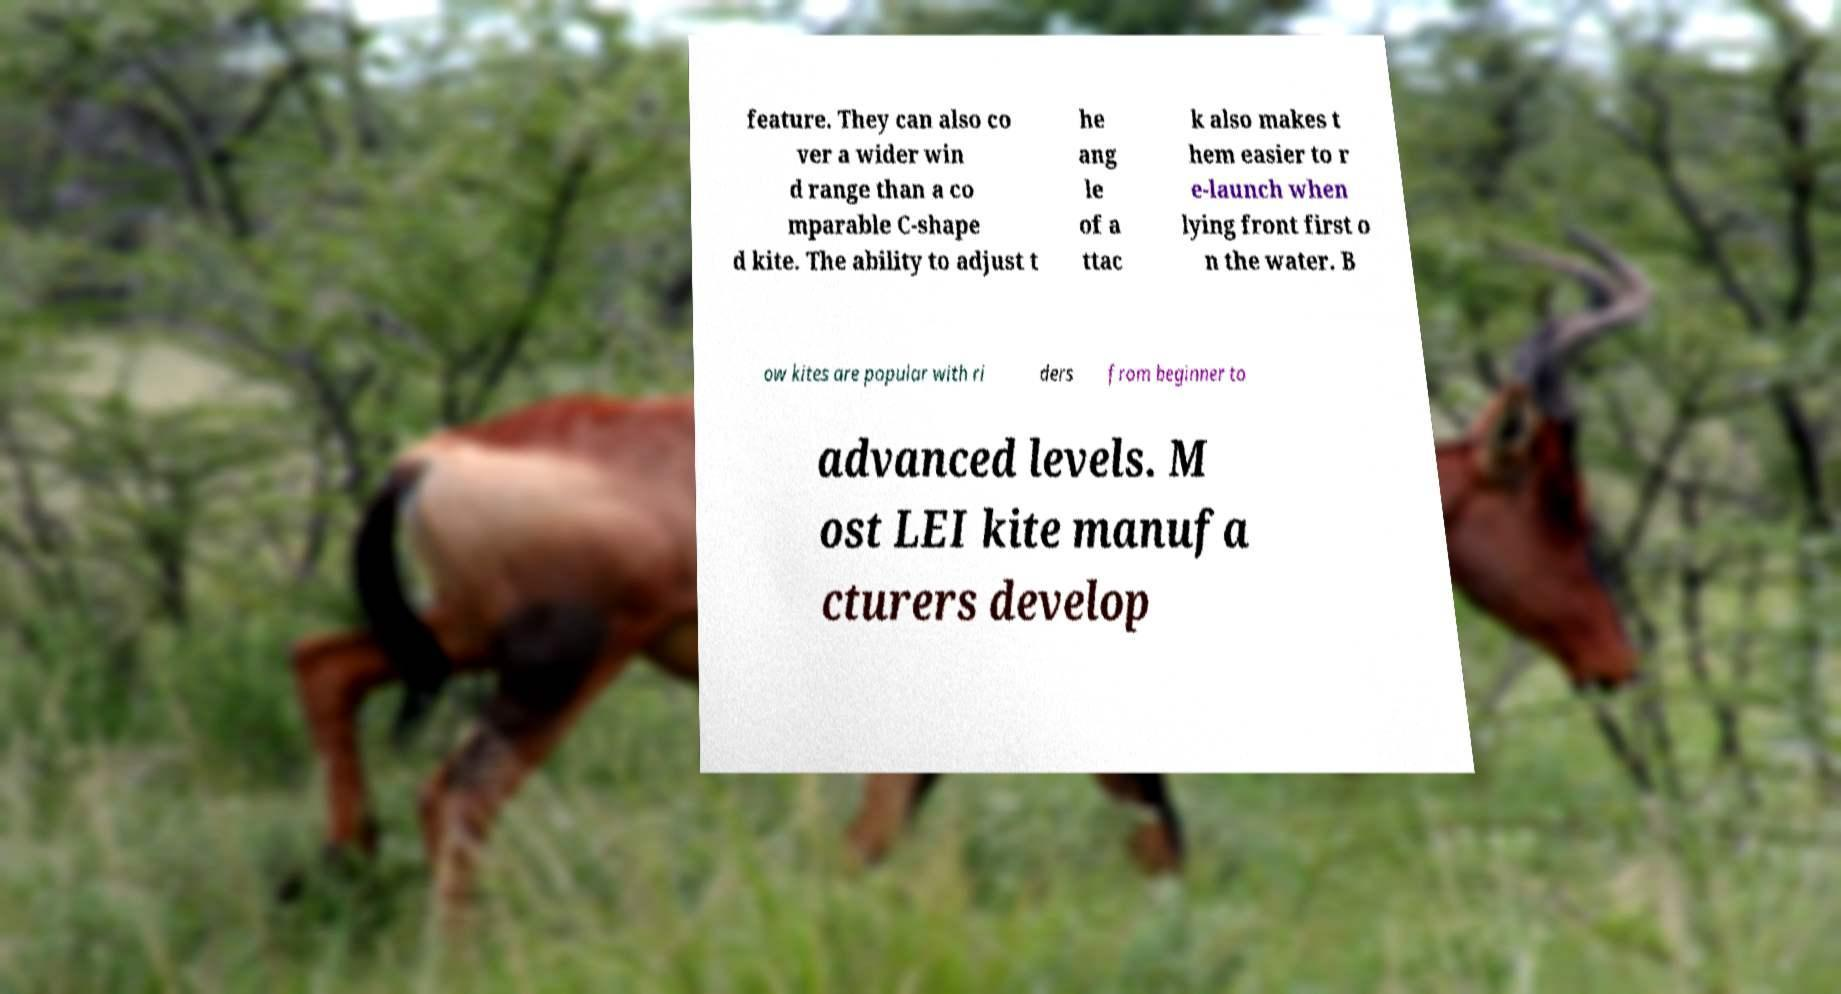I need the written content from this picture converted into text. Can you do that? feature. They can also co ver a wider win d range than a co mparable C-shape d kite. The ability to adjust t he ang le of a ttac k also makes t hem easier to r e-launch when lying front first o n the water. B ow kites are popular with ri ders from beginner to advanced levels. M ost LEI kite manufa cturers develop 